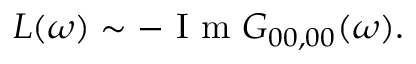<formula> <loc_0><loc_0><loc_500><loc_500>L ( \omega ) \sim - I m G _ { 0 0 , 0 0 } ( \omega ) .</formula> 